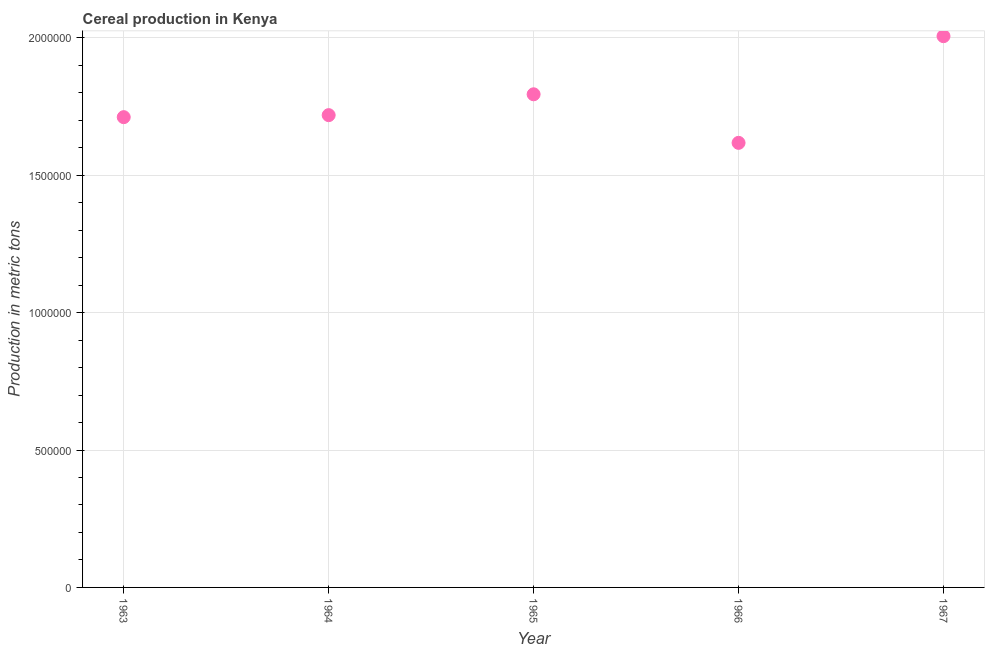What is the cereal production in 1966?
Make the answer very short. 1.62e+06. Across all years, what is the maximum cereal production?
Your response must be concise. 2.01e+06. Across all years, what is the minimum cereal production?
Keep it short and to the point. 1.62e+06. In which year was the cereal production maximum?
Your response must be concise. 1967. In which year was the cereal production minimum?
Offer a terse response. 1966. What is the sum of the cereal production?
Keep it short and to the point. 8.85e+06. What is the difference between the cereal production in 1963 and 1966?
Provide a succinct answer. 9.35e+04. What is the average cereal production per year?
Offer a terse response. 1.77e+06. What is the median cereal production?
Offer a terse response. 1.72e+06. In how many years, is the cereal production greater than 500000 metric tons?
Make the answer very short. 5. What is the ratio of the cereal production in 1964 to that in 1967?
Offer a very short reply. 0.86. What is the difference between the highest and the second highest cereal production?
Offer a terse response. 2.12e+05. What is the difference between the highest and the lowest cereal production?
Keep it short and to the point. 3.88e+05. How many dotlines are there?
Your answer should be compact. 1. Are the values on the major ticks of Y-axis written in scientific E-notation?
Your response must be concise. No. Does the graph contain grids?
Ensure brevity in your answer.  Yes. What is the title of the graph?
Provide a succinct answer. Cereal production in Kenya. What is the label or title of the X-axis?
Ensure brevity in your answer.  Year. What is the label or title of the Y-axis?
Make the answer very short. Production in metric tons. What is the Production in metric tons in 1963?
Give a very brief answer. 1.71e+06. What is the Production in metric tons in 1964?
Your response must be concise. 1.72e+06. What is the Production in metric tons in 1965?
Ensure brevity in your answer.  1.79e+06. What is the Production in metric tons in 1966?
Provide a succinct answer. 1.62e+06. What is the Production in metric tons in 1967?
Your answer should be very brief. 2.01e+06. What is the difference between the Production in metric tons in 1963 and 1964?
Provide a succinct answer. -7363. What is the difference between the Production in metric tons in 1963 and 1965?
Offer a very short reply. -8.32e+04. What is the difference between the Production in metric tons in 1963 and 1966?
Your answer should be compact. 9.35e+04. What is the difference between the Production in metric tons in 1963 and 1967?
Give a very brief answer. -2.95e+05. What is the difference between the Production in metric tons in 1964 and 1965?
Your answer should be compact. -7.58e+04. What is the difference between the Production in metric tons in 1964 and 1966?
Make the answer very short. 1.01e+05. What is the difference between the Production in metric tons in 1964 and 1967?
Your response must be concise. -2.87e+05. What is the difference between the Production in metric tons in 1965 and 1966?
Your answer should be compact. 1.77e+05. What is the difference between the Production in metric tons in 1965 and 1967?
Your answer should be compact. -2.12e+05. What is the difference between the Production in metric tons in 1966 and 1967?
Offer a terse response. -3.88e+05. What is the ratio of the Production in metric tons in 1963 to that in 1965?
Provide a short and direct response. 0.95. What is the ratio of the Production in metric tons in 1963 to that in 1966?
Offer a terse response. 1.06. What is the ratio of the Production in metric tons in 1963 to that in 1967?
Give a very brief answer. 0.85. What is the ratio of the Production in metric tons in 1964 to that in 1965?
Your response must be concise. 0.96. What is the ratio of the Production in metric tons in 1964 to that in 1966?
Keep it short and to the point. 1.06. What is the ratio of the Production in metric tons in 1964 to that in 1967?
Your answer should be very brief. 0.86. What is the ratio of the Production in metric tons in 1965 to that in 1966?
Provide a short and direct response. 1.11. What is the ratio of the Production in metric tons in 1965 to that in 1967?
Offer a very short reply. 0.9. What is the ratio of the Production in metric tons in 1966 to that in 1967?
Offer a terse response. 0.81. 